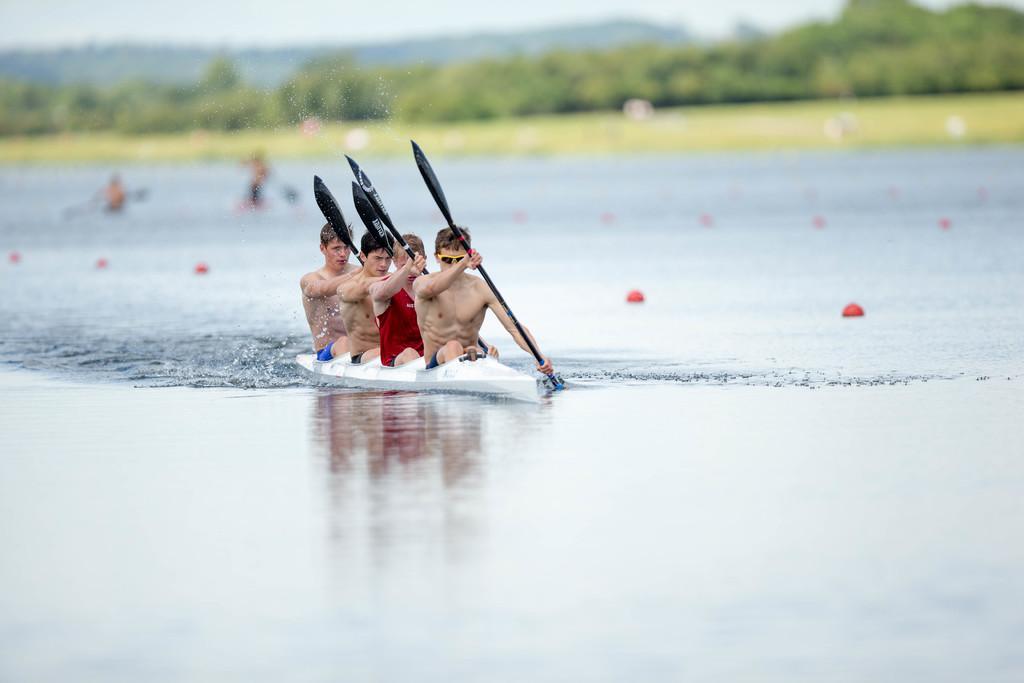How would you summarize this image in a sentence or two? In the front of the image I can see water, people, boat and paddles. People are sitting in a boat and holding paddles. In the background of the image it is blurry. There are trees, people, and objects.   